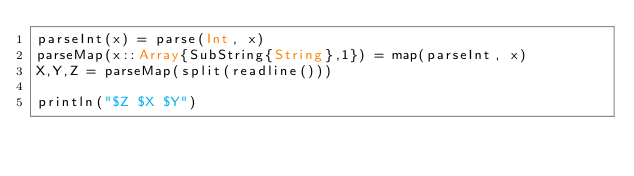Convert code to text. <code><loc_0><loc_0><loc_500><loc_500><_Julia_>parseInt(x) = parse(Int, x)
parseMap(x::Array{SubString{String},1}) = map(parseInt, x)
X,Y,Z = parseMap(split(readline()))

println("$Z $X $Y")
</code> 